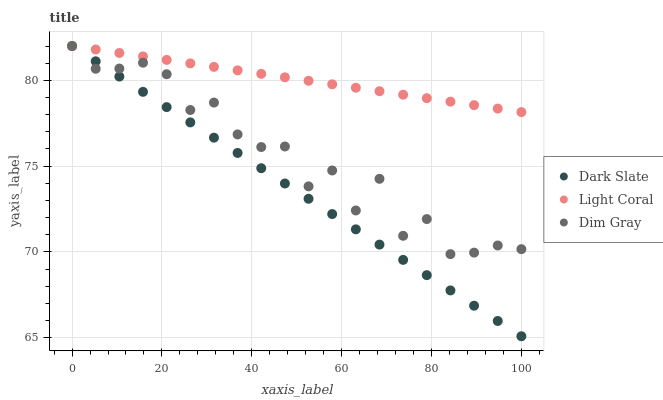Does Dark Slate have the minimum area under the curve?
Answer yes or no. Yes. Does Light Coral have the maximum area under the curve?
Answer yes or no. Yes. Does Dim Gray have the minimum area under the curve?
Answer yes or no. No. Does Dim Gray have the maximum area under the curve?
Answer yes or no. No. Is Light Coral the smoothest?
Answer yes or no. Yes. Is Dim Gray the roughest?
Answer yes or no. Yes. Is Dark Slate the smoothest?
Answer yes or no. No. Is Dark Slate the roughest?
Answer yes or no. No. Does Dark Slate have the lowest value?
Answer yes or no. Yes. Does Dim Gray have the lowest value?
Answer yes or no. No. Does Dim Gray have the highest value?
Answer yes or no. Yes. Does Light Coral intersect Dark Slate?
Answer yes or no. Yes. Is Light Coral less than Dark Slate?
Answer yes or no. No. Is Light Coral greater than Dark Slate?
Answer yes or no. No. 